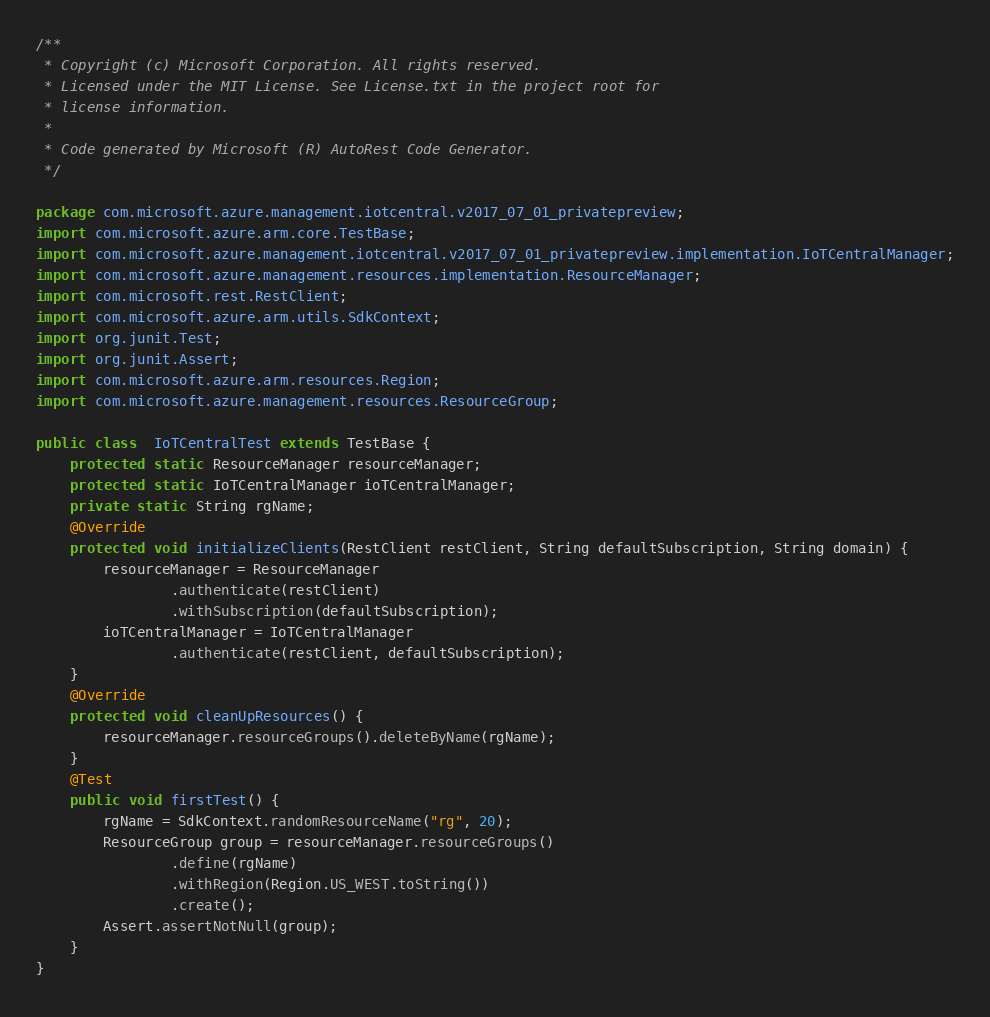<code> <loc_0><loc_0><loc_500><loc_500><_Java_>/**
 * Copyright (c) Microsoft Corporation. All rights reserved.
 * Licensed under the MIT License. See License.txt in the project root for
 * license information.
 *
 * Code generated by Microsoft (R) AutoRest Code Generator.
 */

package com.microsoft.azure.management.iotcentral.v2017_07_01_privatepreview;
import com.microsoft.azure.arm.core.TestBase;
import com.microsoft.azure.management.iotcentral.v2017_07_01_privatepreview.implementation.IoTCentralManager;
import com.microsoft.azure.management.resources.implementation.ResourceManager;
import com.microsoft.rest.RestClient;
import com.microsoft.azure.arm.utils.SdkContext;
import org.junit.Test;
import org.junit.Assert;
import com.microsoft.azure.arm.resources.Region;
import com.microsoft.azure.management.resources.ResourceGroup;

public class  IoTCentralTest extends TestBase {
    protected static ResourceManager resourceManager;
    protected static IoTCentralManager ioTCentralManager;
    private static String rgName;
    @Override
    protected void initializeClients(RestClient restClient, String defaultSubscription, String domain) {
        resourceManager = ResourceManager
                .authenticate(restClient)
                .withSubscription(defaultSubscription);
        ioTCentralManager = IoTCentralManager
                .authenticate(restClient, defaultSubscription);
    }
    @Override
    protected void cleanUpResources() {
        resourceManager.resourceGroups().deleteByName(rgName);
    }
    @Test
    public void firstTest() {
        rgName = SdkContext.randomResourceName("rg", 20);
        ResourceGroup group = resourceManager.resourceGroups()
                .define(rgName)
                .withRegion(Region.US_WEST.toString())
                .create();
        Assert.assertNotNull(group);
    }
}
</code> 